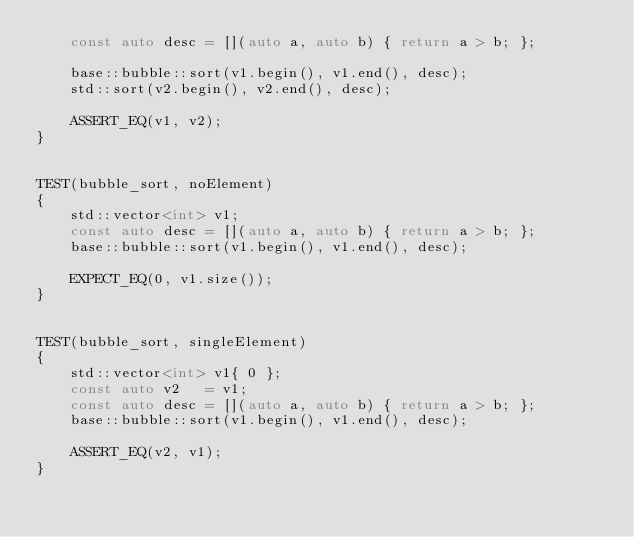Convert code to text. <code><loc_0><loc_0><loc_500><loc_500><_C++_>	const auto desc = [](auto a, auto b) { return a > b; };

	base::bubble::sort(v1.begin(), v1.end(), desc);
	std::sort(v2.begin(), v2.end(), desc);

	ASSERT_EQ(v1, v2);
}


TEST(bubble_sort, noElement)
{
	std::vector<int> v1;
	const auto desc = [](auto a, auto b) { return a > b; };
	base::bubble::sort(v1.begin(), v1.end(), desc);

	EXPECT_EQ(0, v1.size());
}


TEST(bubble_sort, singleElement)
{
	std::vector<int> v1{ 0 };
	const auto v2   = v1;
	const auto desc = [](auto a, auto b) { return a > b; };
	base::bubble::sort(v1.begin(), v1.end(), desc);

	ASSERT_EQ(v2, v1);
}
</code> 